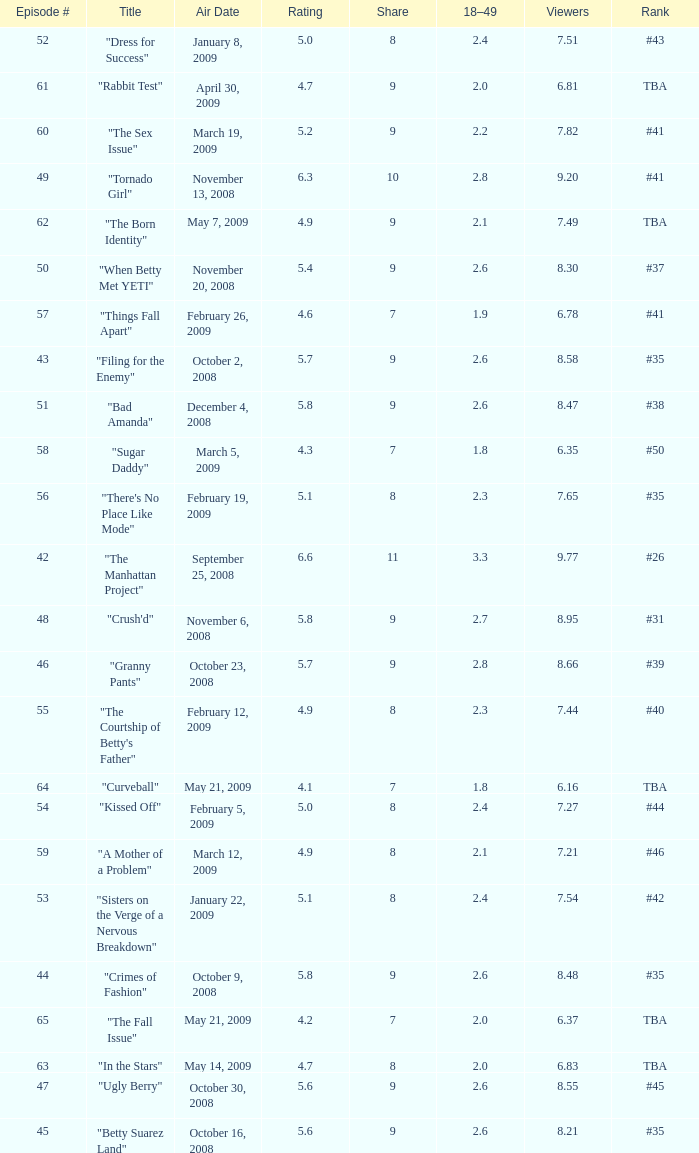What is the average Episode # with a 7 share and 18–49 is less than 2 and the Air Date of may 21, 2009? 64.0. 